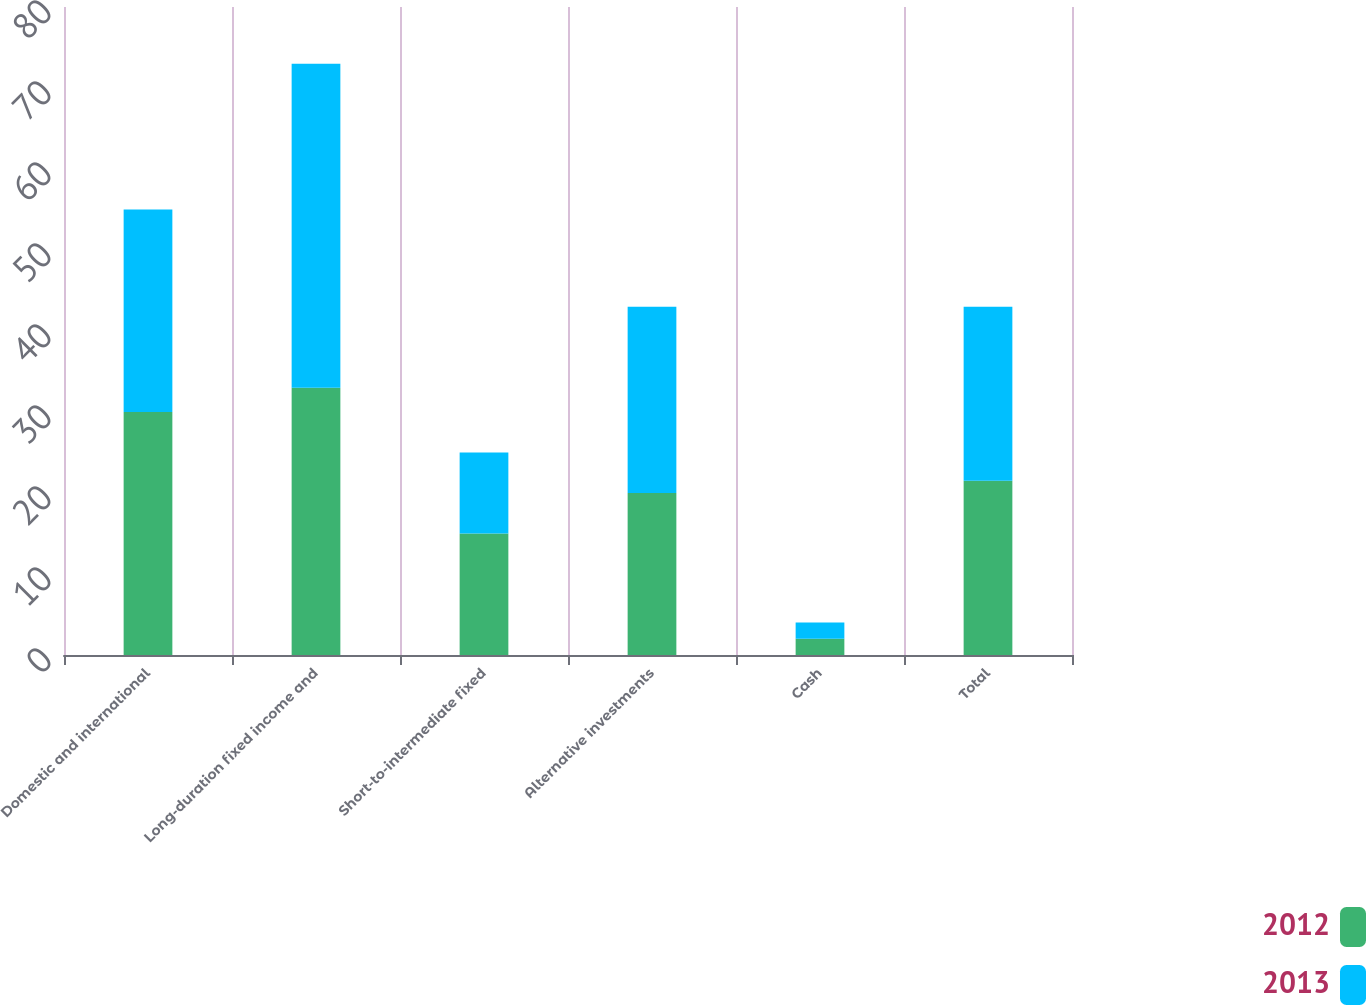Convert chart to OTSL. <chart><loc_0><loc_0><loc_500><loc_500><stacked_bar_chart><ecel><fcel>Domestic and international<fcel>Long-duration fixed income and<fcel>Short-to-intermediate fixed<fcel>Alternative investments<fcel>Cash<fcel>Total<nl><fcel>2012<fcel>30<fcel>33<fcel>15<fcel>20<fcel>2<fcel>21.5<nl><fcel>2013<fcel>25<fcel>40<fcel>10<fcel>23<fcel>2<fcel>21.5<nl></chart> 